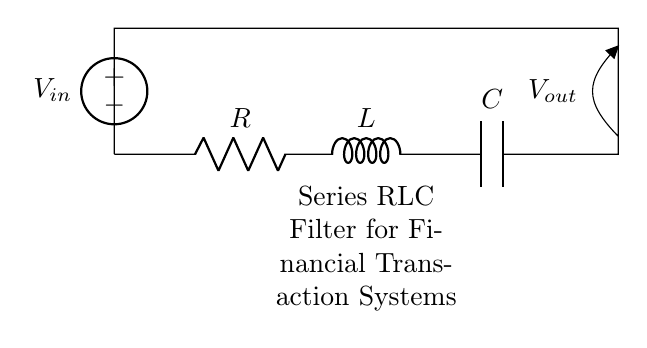What components are present in this circuit? The circuit includes a resistor, inductor, and capacitor arranged in series, typical of a series RLC circuit.
Answer: Resistor, inductor, capacitor What is the purpose of the voltage source? The voltage source provides the input voltage needed to power the circuit, thus enabling the filtering of any noise in the system.
Answer: Input voltage What is the output voltage relative to the input voltage? The output voltage may vary based on the frequency of the input signal and the values of the resistor, inductor, and capacitor; it’s not a fixed number shown in the diagram.
Answer: Vout How does the inductor behave at high frequencies? At high frequencies, the inductor presents a high impedance, which will limit the current flow and affect the output voltage significantly.
Answer: High impedance What type of filter does this circuit represent? This configuration acts as a series bandpass filter allowing certain frequencies to pass while attenuating others, effectively filtering noise in financial transaction systems.
Answer: Bandpass filter What would happen if the capacitor's value is increased? Increasing the capacitor's value lowers the cutoff frequency, allowing more low-frequency signals to pass through while blocking higher frequencies.
Answer: Lower cutoff frequency 